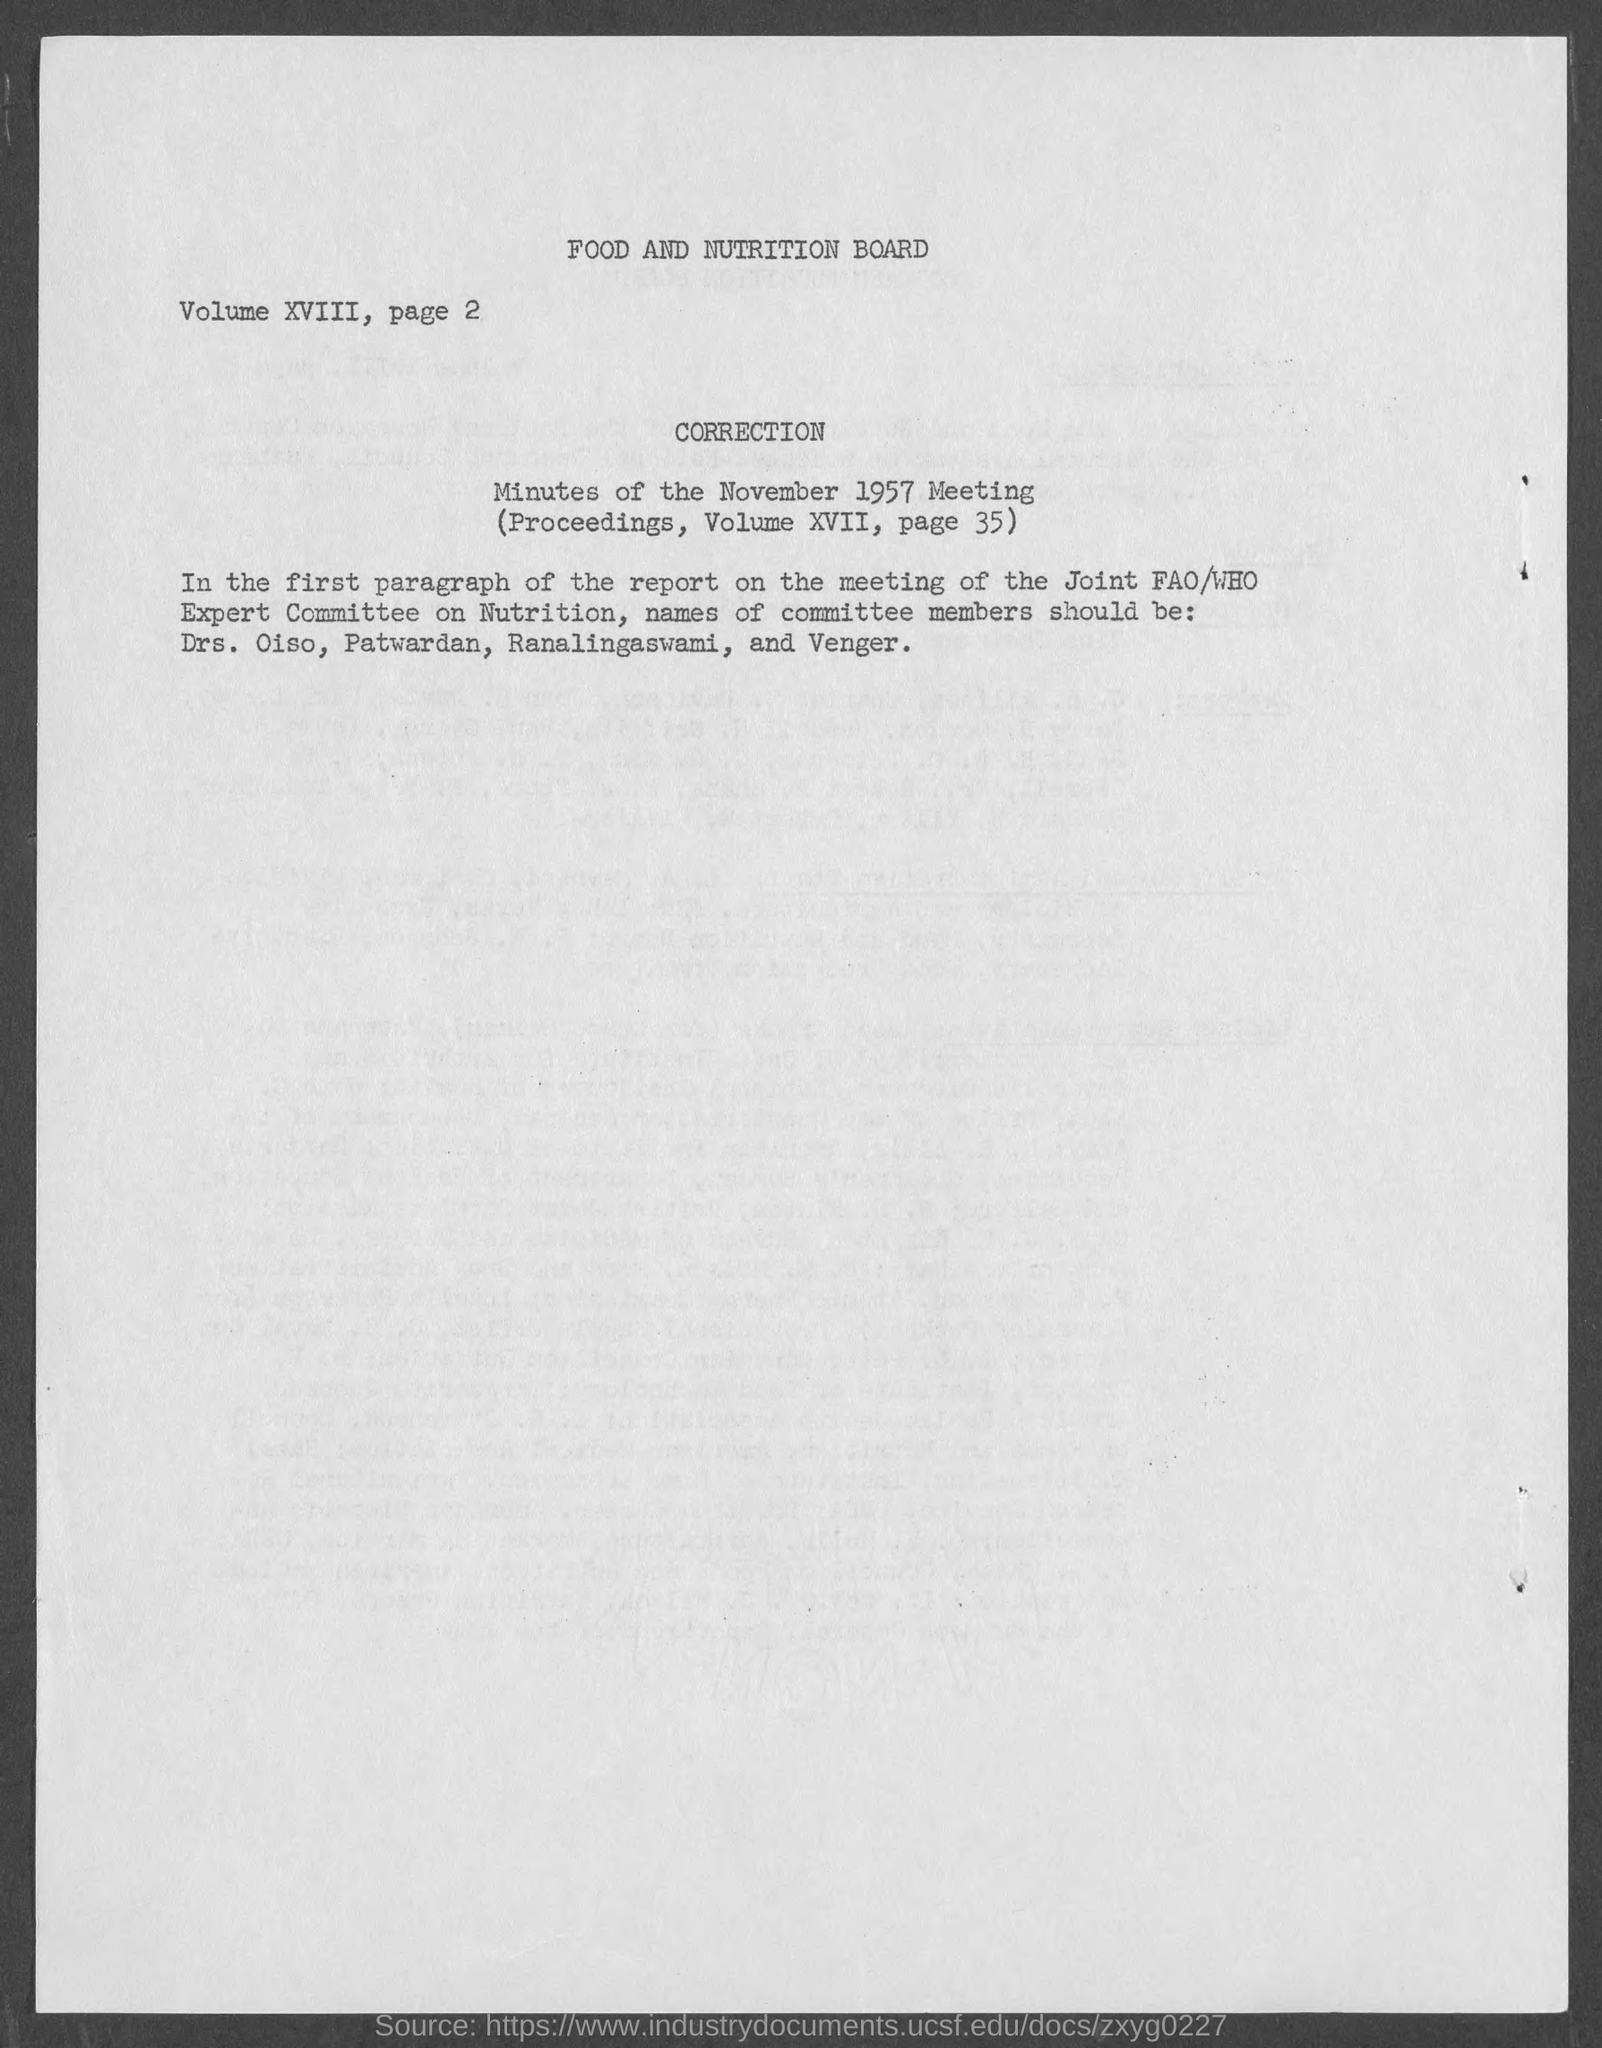Mention a couple of crucial points in this snapshot. The document titled 'Minutes of the November 1957 Meeting' is mentioned in a record, and the mention specifies that it appears on page 35. Correction is on the first paragraph of the report. The title of the document is "Food and Nutrition Board. The minutes of the November 1957 meeting are as follows... The fact that the book "Minutes of the November 1957 Meeting" is mentioned in a volume, specifically volume xvii, is mentioned. 